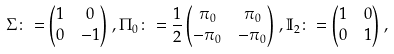<formula> <loc_0><loc_0><loc_500><loc_500>& \Sigma \colon = \begin{pmatrix} 1 & 0 \\ 0 & - 1 \end{pmatrix} \, , \Pi _ { 0 } \colon = \frac { 1 } { 2 } \begin{pmatrix} \pi _ { 0 } & \pi _ { 0 } \\ - \pi _ { 0 } & - \pi _ { 0 } \end{pmatrix} \, , { \mathbb { I } } _ { 2 } \colon = \begin{pmatrix} 1 & 0 \\ 0 & 1 \end{pmatrix} \, ,</formula> 